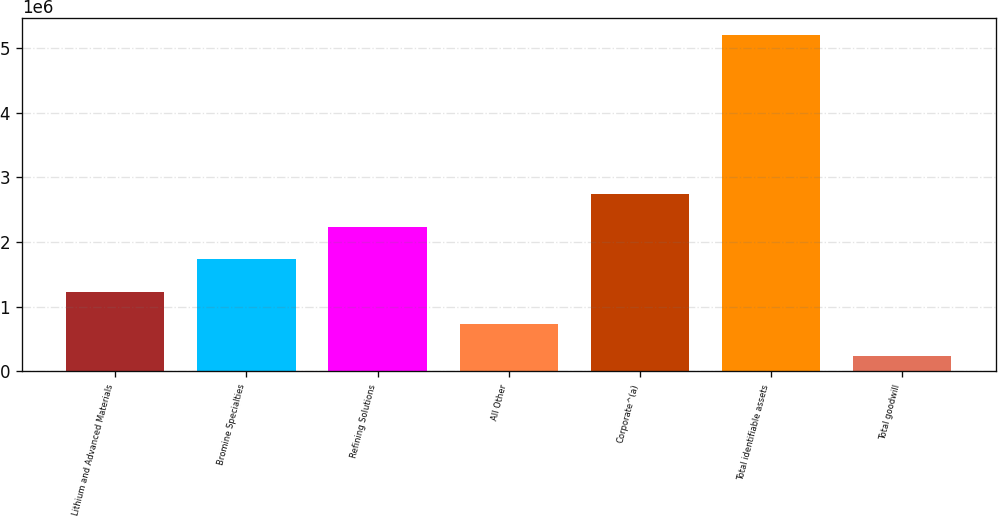<chart> <loc_0><loc_0><loc_500><loc_500><bar_chart><fcel>Lithium and Advanced Materials<fcel>Bromine Specialties<fcel>Refining Solutions<fcel>All Other<fcel>Corporate^(a)<fcel>Total identifiable assets<fcel>Total goodwill<nl><fcel>1.2351e+06<fcel>1.73101e+06<fcel>2.22693e+06<fcel>739180<fcel>2.74828e+06<fcel>5.20244e+06<fcel>243262<nl></chart> 